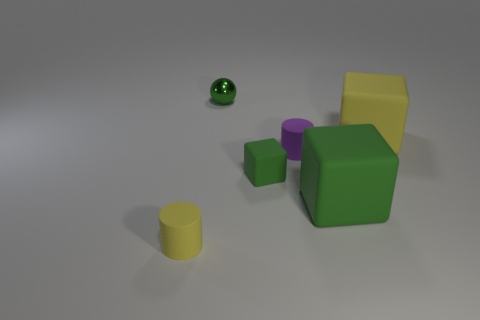How many small things are both left of the small rubber block and in front of the large yellow block?
Offer a terse response. 1. What shape is the large yellow object that is made of the same material as the purple object?
Offer a terse response. Cube. There is a block behind the small cube; is its size the same as the rubber cube on the left side of the purple thing?
Keep it short and to the point. No. What color is the cylinder that is behind the small yellow cylinder?
Ensure brevity in your answer.  Purple. What is the material of the big block to the left of the big matte thing behind the tiny purple matte object?
Provide a short and direct response. Rubber. What shape is the tiny purple thing?
Give a very brief answer. Cylinder. There is another big thing that is the same shape as the large yellow thing; what is it made of?
Make the answer very short. Rubber. How many yellow cubes are the same size as the purple cylinder?
Offer a very short reply. 0. There is a matte block on the left side of the big green rubber block; are there any small matte cylinders left of it?
Your response must be concise. Yes. How many green objects are either big objects or spheres?
Give a very brief answer. 2. 